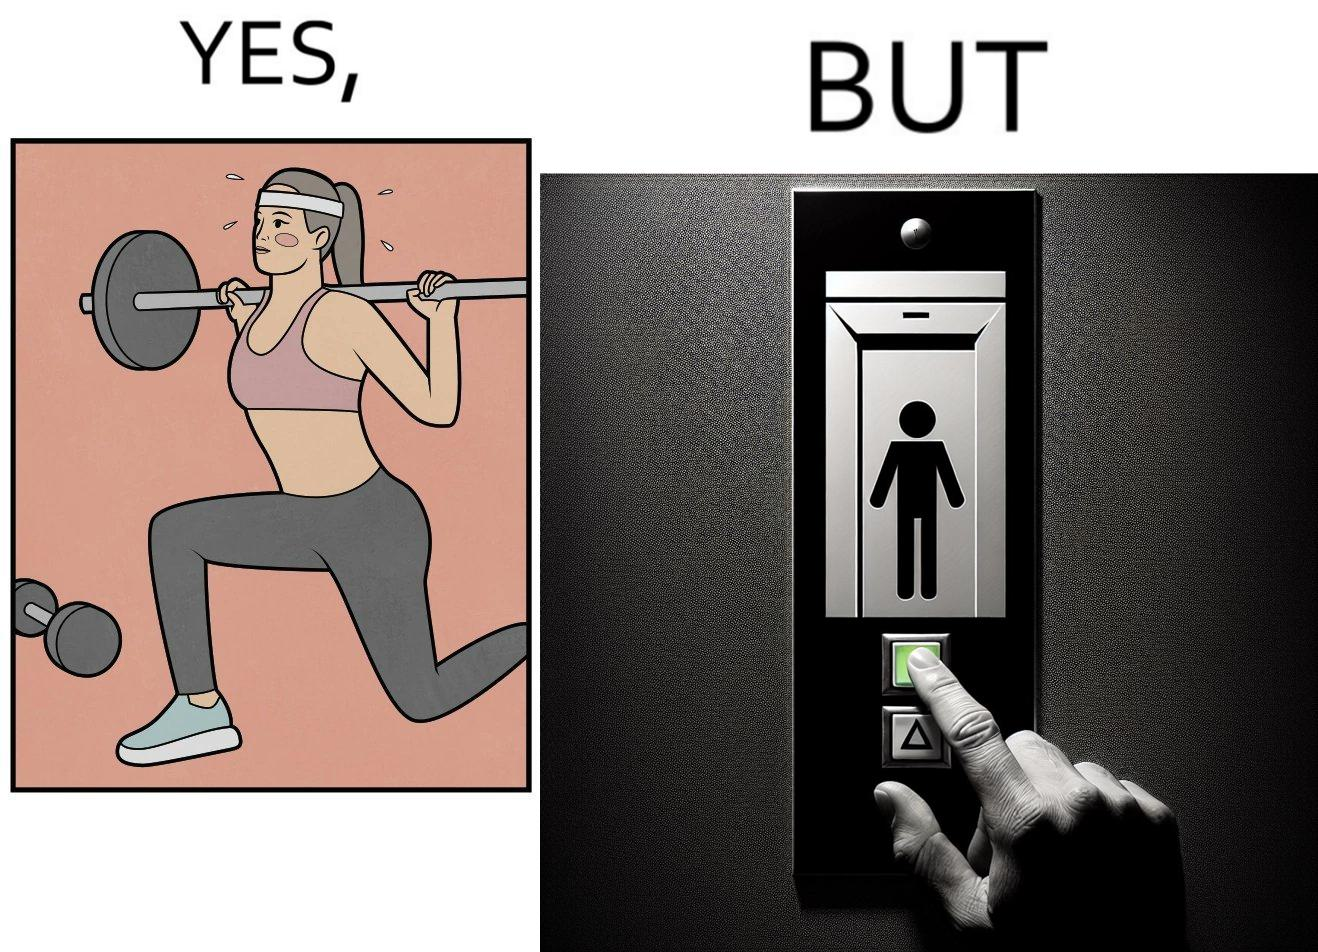What is the satirical meaning behind this image? The image is satirical because it shows that while people do various kinds of exercises and go to gym to stay fit, they avoid doing simplest of physical tasks like using stairs instead of elevators to get to even the first or the second floor of a building. 